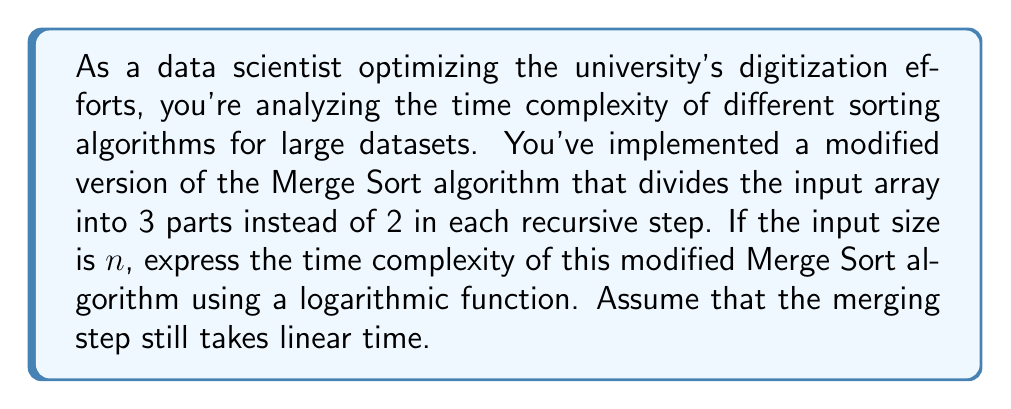Provide a solution to this math problem. To solve this problem, let's break it down step by step:

1) In a standard Merge Sort, the recurrence relation is $T(n) = 2T(n/2) + O(n)$, because it divides the input into 2 parts.

2) In our modified version, we're dividing the input into 3 parts. So, our new recurrence relation becomes:

   $T(n) = 3T(n/3) + O(n)$

3) This recurrence relation falls under the Master Theorem case where $a = 3$, $b = 3$, and $f(n) = O(n)$.

4) According to the Master Theorem, if $f(n) = O(n^{\log_b a - \epsilon})$ for some constant $\epsilon > 0$, then $T(n) = \Theta(n^{\log_b a})$.

5) In our case:
   $\log_b a = \log_3 3 = 1$

6) Since $f(n) = O(n) = O(n^{\log_3 3})$, we fall into the case where $f(n) = \Theta(n^{\log_b a})$.

7) For this case, the time complexity is:

   $T(n) = \Theta(n^{\log_b a} \log n) = \Theta(n \log n)$

8) Therefore, the time complexity of our modified Merge Sort is $\Theta(n \log n)$.

9) To express this using a logarithmic function, we can write it as:

   $T(n) = \Theta(n \log_3 n)$

   Note that we use $\log_3$ because our algorithm divides the input into 3 parts at each step. However, the base of the logarithm doesn't affect the overall complexity class, as $\log_a n = \frac{\log_b n}{\log_b a}$ for any bases $a$ and $b$.
Answer: $T(n) = \Theta(n \log_3 n)$ 